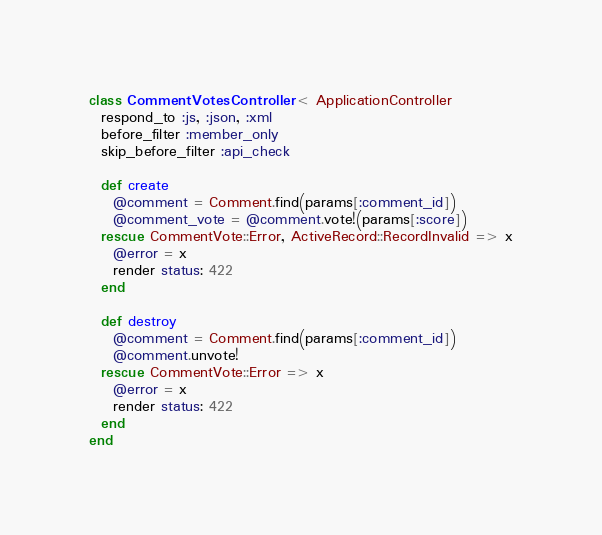<code> <loc_0><loc_0><loc_500><loc_500><_Ruby_>class CommentVotesController < ApplicationController
  respond_to :js, :json, :xml
  before_filter :member_only
  skip_before_filter :api_check

  def create
    @comment = Comment.find(params[:comment_id])
    @comment_vote = @comment.vote!(params[:score])
  rescue CommentVote::Error, ActiveRecord::RecordInvalid => x
    @error = x
    render status: 422
  end

  def destroy
    @comment = Comment.find(params[:comment_id])
    @comment.unvote!
  rescue CommentVote::Error => x
    @error = x
    render status: 422
  end
end
</code> 